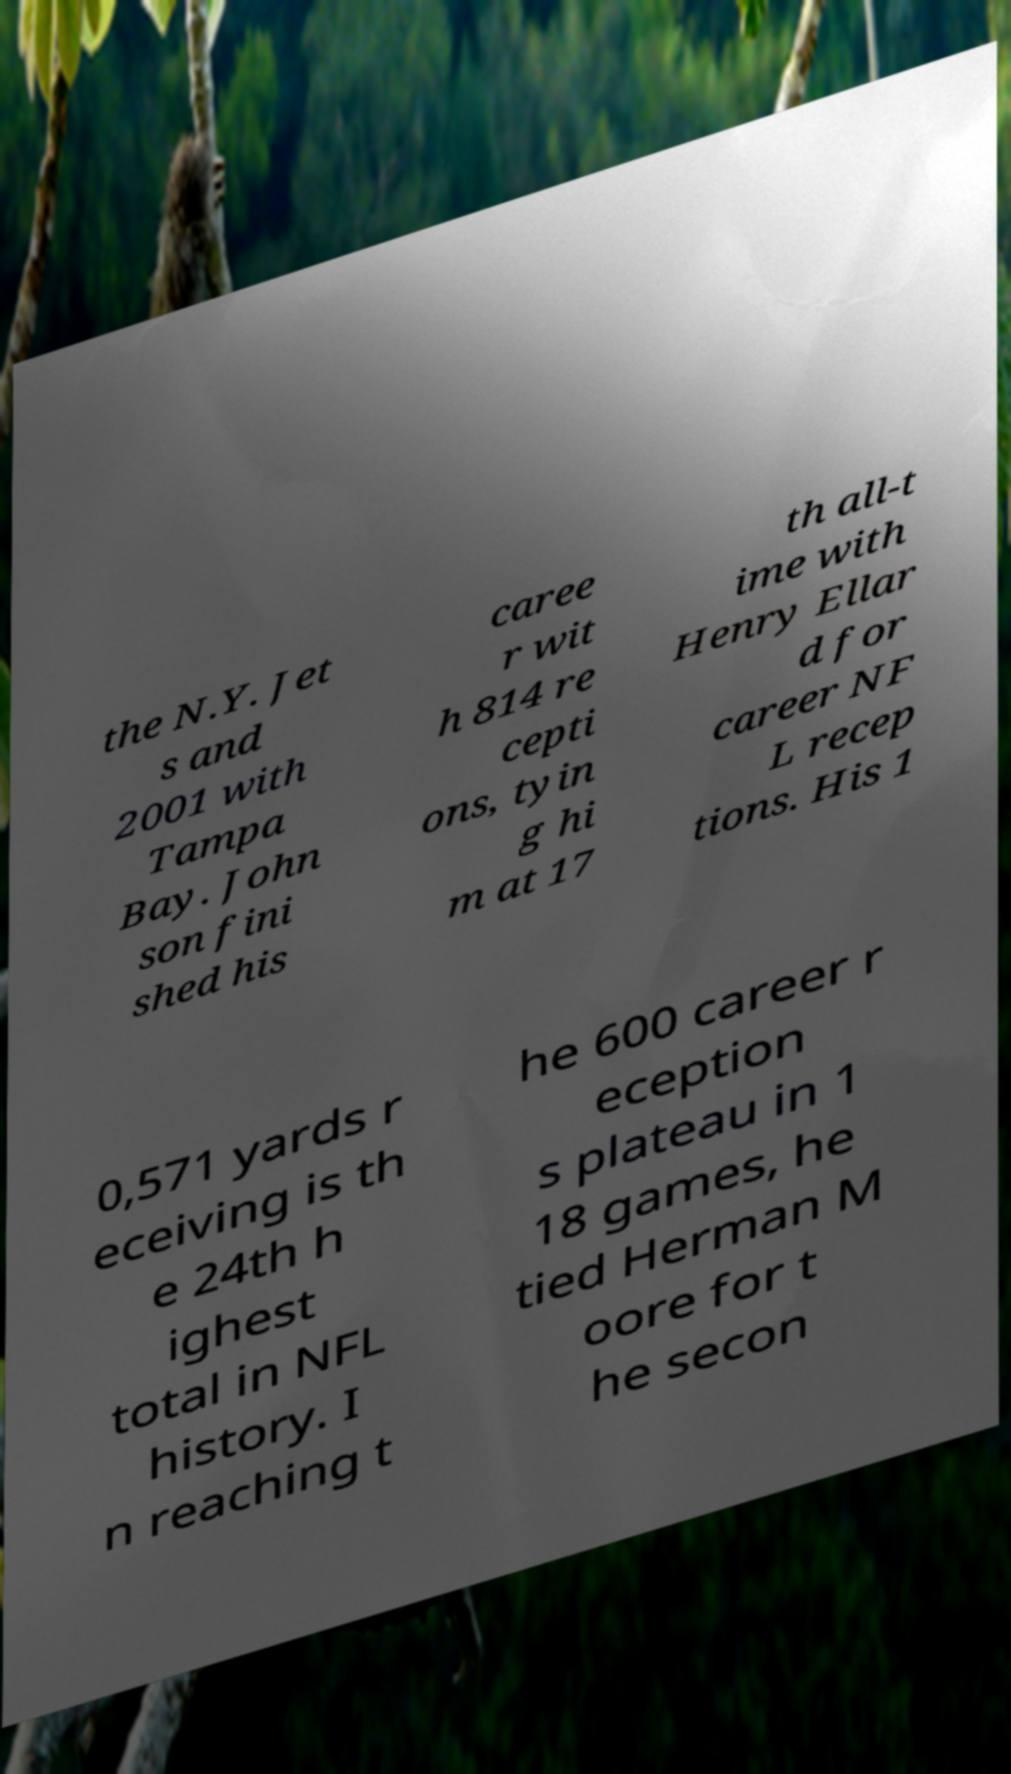There's text embedded in this image that I need extracted. Can you transcribe it verbatim? the N.Y. Jet s and 2001 with Tampa Bay. John son fini shed his caree r wit h 814 re cepti ons, tyin g hi m at 17 th all-t ime with Henry Ellar d for career NF L recep tions. His 1 0,571 yards r eceiving is th e 24th h ighest total in NFL history. I n reaching t he 600 career r eception s plateau in 1 18 games, he tied Herman M oore for t he secon 